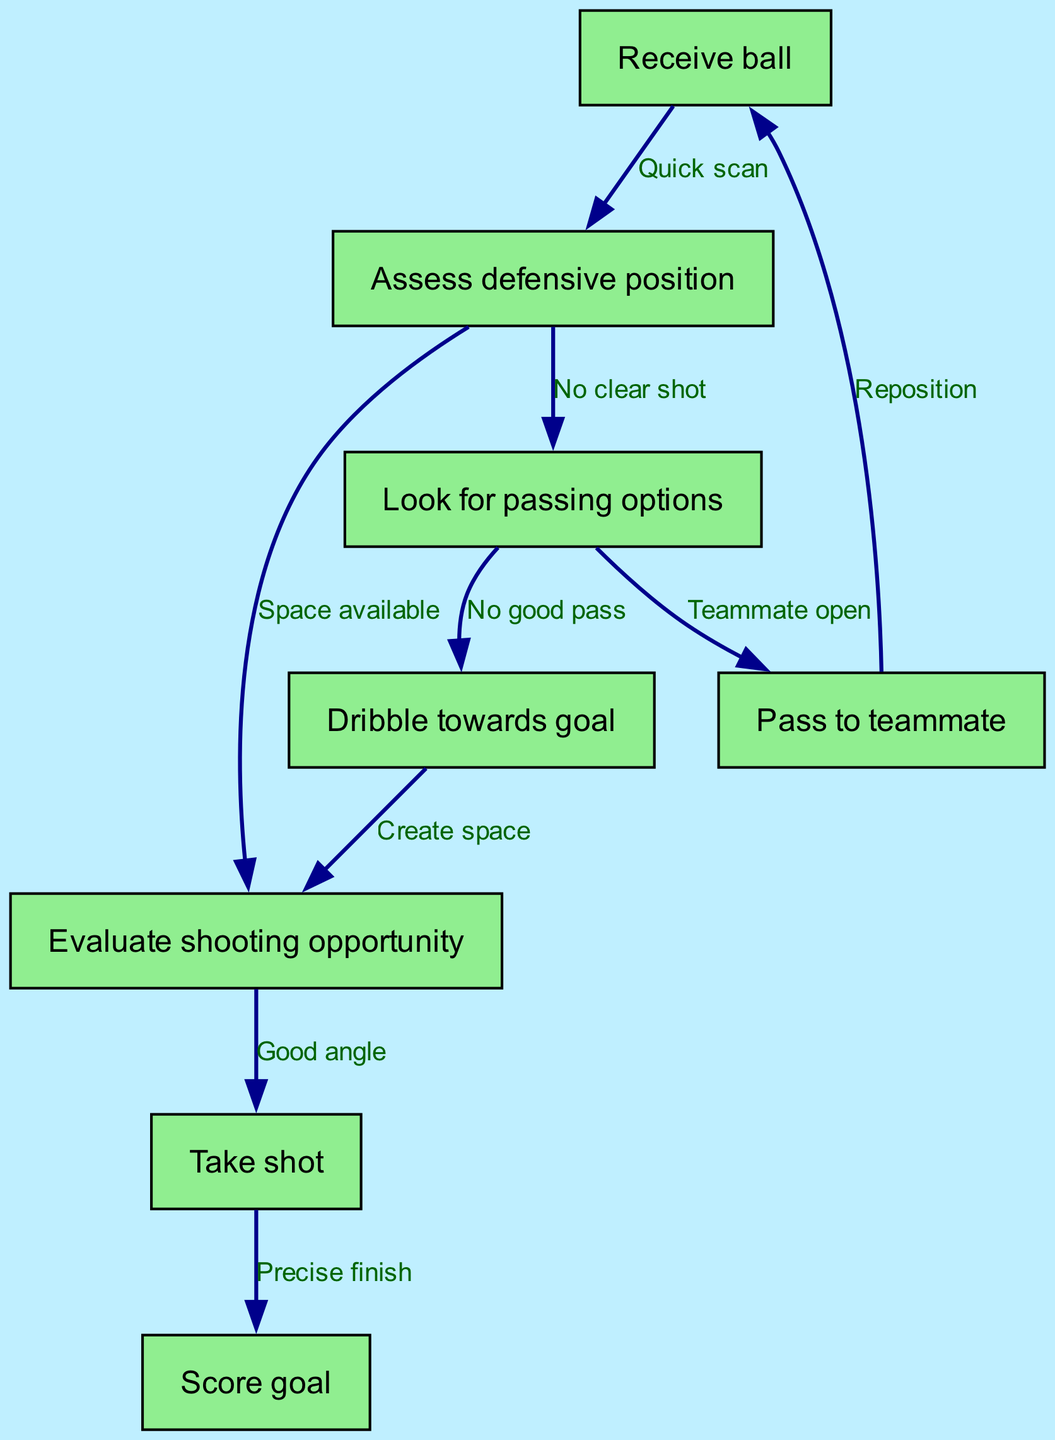What is the first step in the decision-making process of a striker? The first node in the diagram is "Receive ball," which indicates the initial action of the striker upon getting the ball.
Answer: Receive ball How many nodes are represented in the flowchart? The flowchart contains 8 nodes, which represent different stages in the decision-making process of the striker.
Answer: 8 What happens if there is no clear shot after assessing defensive position? According to the diagram, if there is no clear shot, the flow moves to "Look for passing options," which means the striker would consider passing the ball.
Answer: Look for passing options Which node connects to both "Teammate open" and "No good pass"? The node "Look for passing options" connects to both "Teammate open" and "No good pass," showing two possible actions the striker can take based on the situation.
Answer: Look for passing options What action follows if the striker evaluates a good angle? The next action after evaluating a good angle is "Take shot," indicating the striker decides to attempt a shot at the goal.
Answer: Take shot What is the relationship between "Pass to teammate" and "Reposition"? The edge from "Pass to teammate" to "Receive ball" is labeled "Reposition," meaning after passing, the striker should reposition themselves, possibly for creating a new opportunity.
Answer: Reposition If a striker decides to dribble towards the goal, what is the next step in the flowchart? If the striker dribbles towards the goal, the next step is to "Evaluate shooting opportunity," indicating they will assess if they can take a shot.
Answer: Evaluate shooting opportunity What is the final outcome of the decision-making process illustrated in this flowchart? The final outcome after following the decision-making process is to "Score goal," which is the ultimate objective of the striker during a match.
Answer: Score goal 